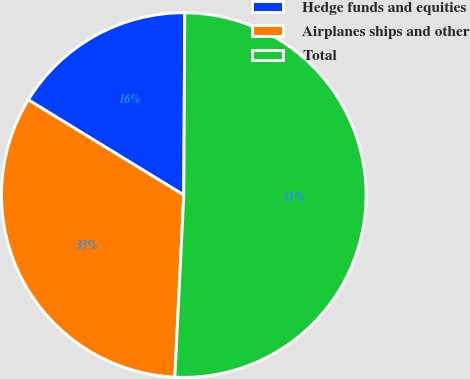Convert chart. <chart><loc_0><loc_0><loc_500><loc_500><pie_chart><fcel>Hedge funds and equities<fcel>Airplanes ships and other<fcel>Total<nl><fcel>16.34%<fcel>32.96%<fcel>50.69%<nl></chart> 